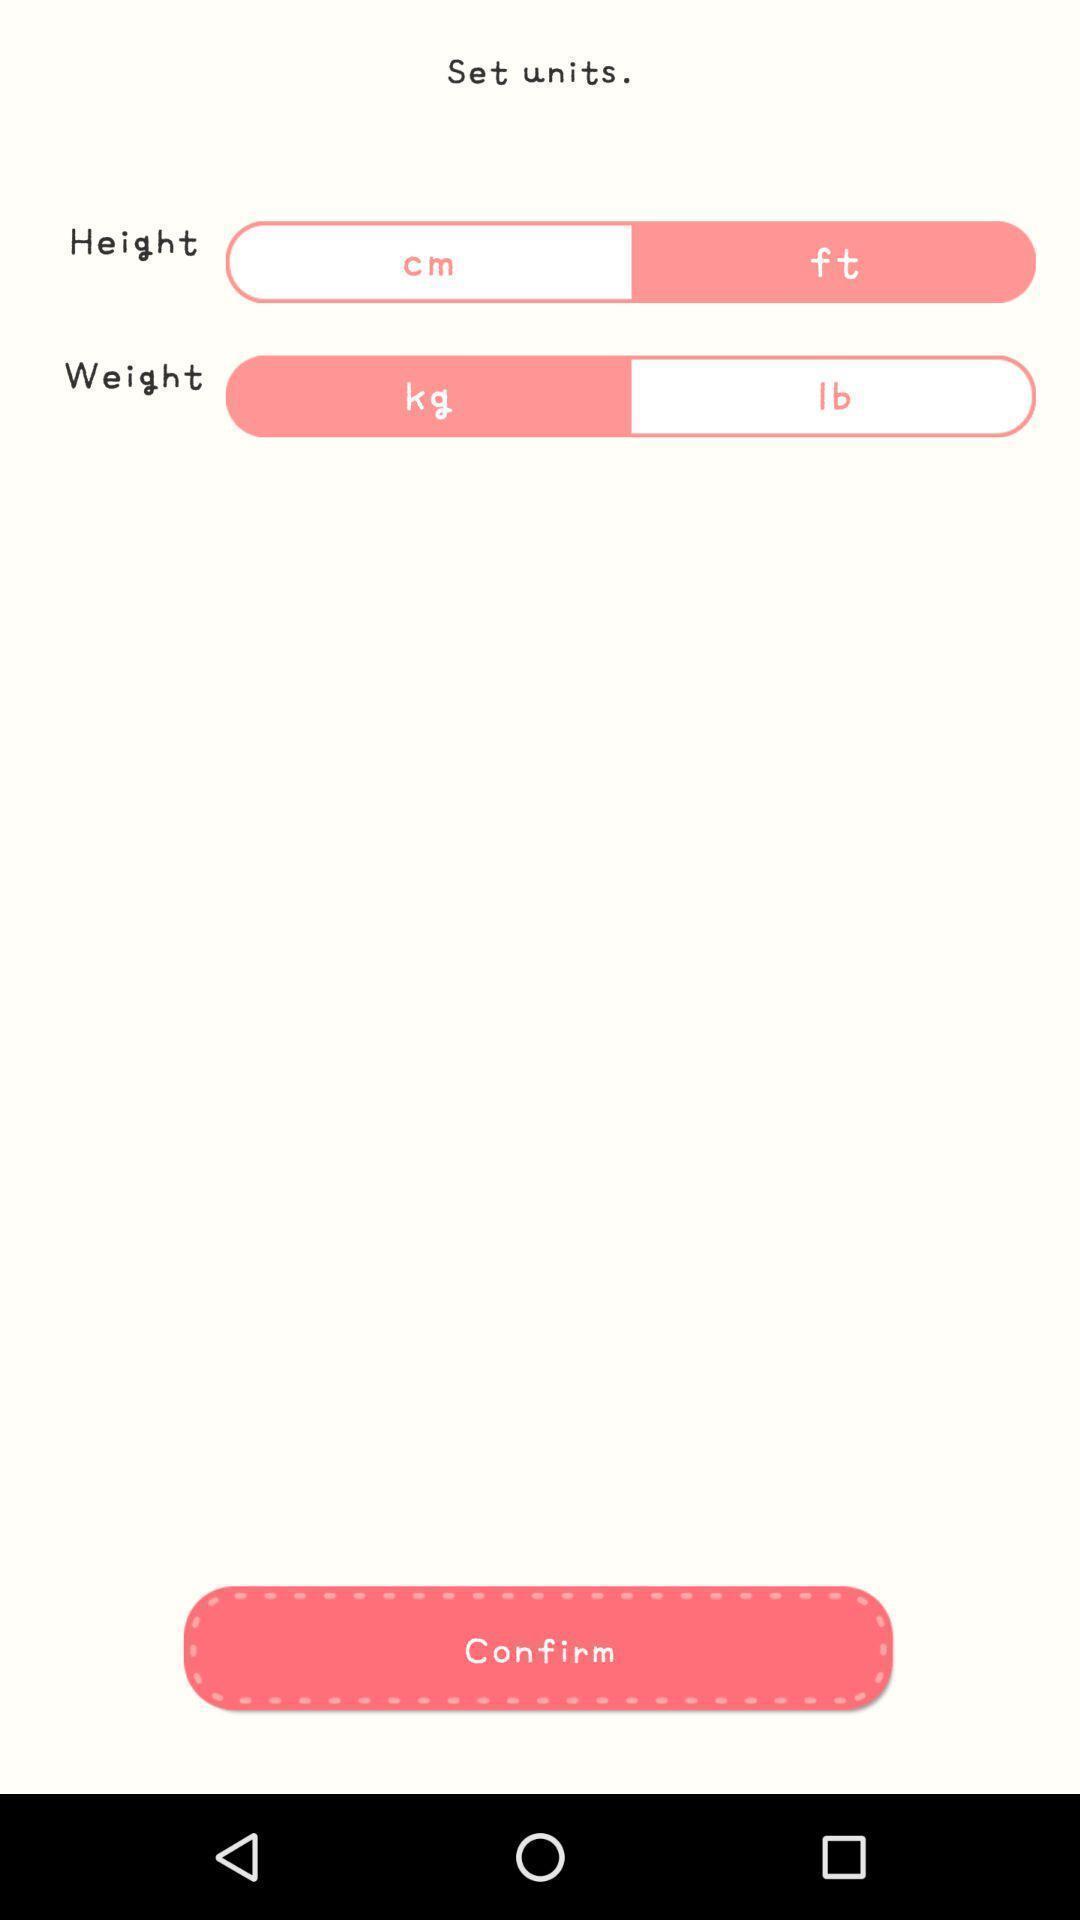Describe this image in words. Screen displaying the units page. 